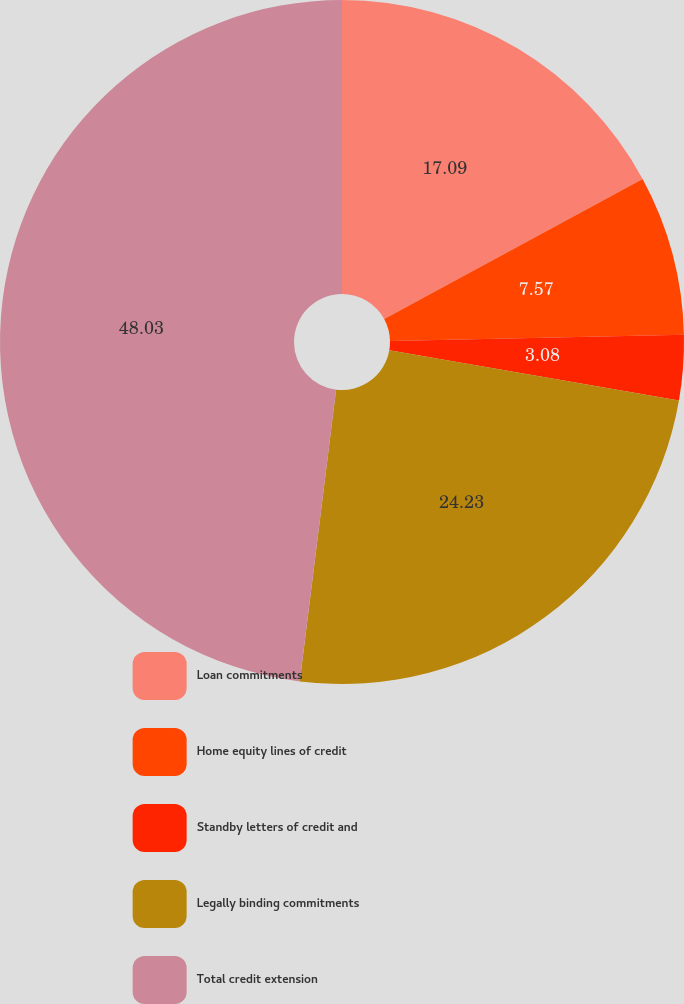<chart> <loc_0><loc_0><loc_500><loc_500><pie_chart><fcel>Loan commitments<fcel>Home equity lines of credit<fcel>Standby letters of credit and<fcel>Legally binding commitments<fcel>Total credit extension<nl><fcel>17.09%<fcel>7.57%<fcel>3.08%<fcel>24.23%<fcel>48.03%<nl></chart> 